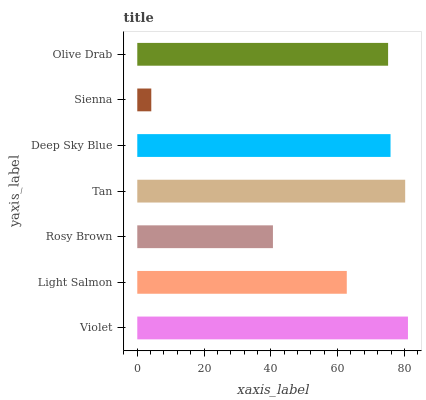Is Sienna the minimum?
Answer yes or no. Yes. Is Violet the maximum?
Answer yes or no. Yes. Is Light Salmon the minimum?
Answer yes or no. No. Is Light Salmon the maximum?
Answer yes or no. No. Is Violet greater than Light Salmon?
Answer yes or no. Yes. Is Light Salmon less than Violet?
Answer yes or no. Yes. Is Light Salmon greater than Violet?
Answer yes or no. No. Is Violet less than Light Salmon?
Answer yes or no. No. Is Olive Drab the high median?
Answer yes or no. Yes. Is Olive Drab the low median?
Answer yes or no. Yes. Is Light Salmon the high median?
Answer yes or no. No. Is Light Salmon the low median?
Answer yes or no. No. 